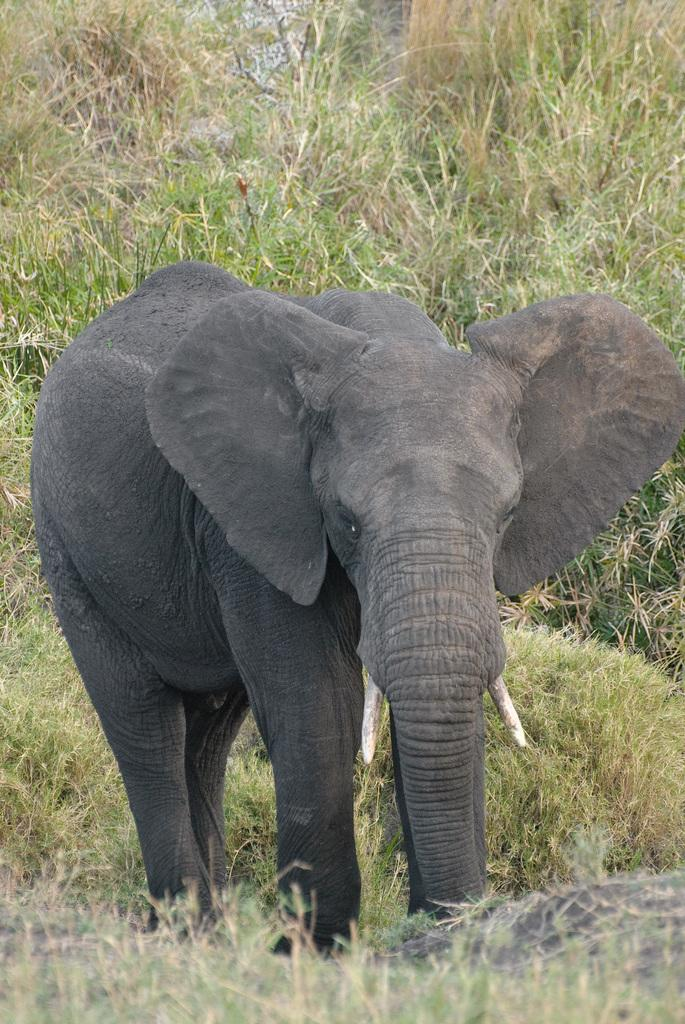What is the main subject of the image? There is an elephant in the middle of the image. What can be seen in the background of the image? There is grass visible in the background of the image. What type of shoe is the elephant wearing in the image? There is no shoe present in the image, as elephants do not wear shoes. 